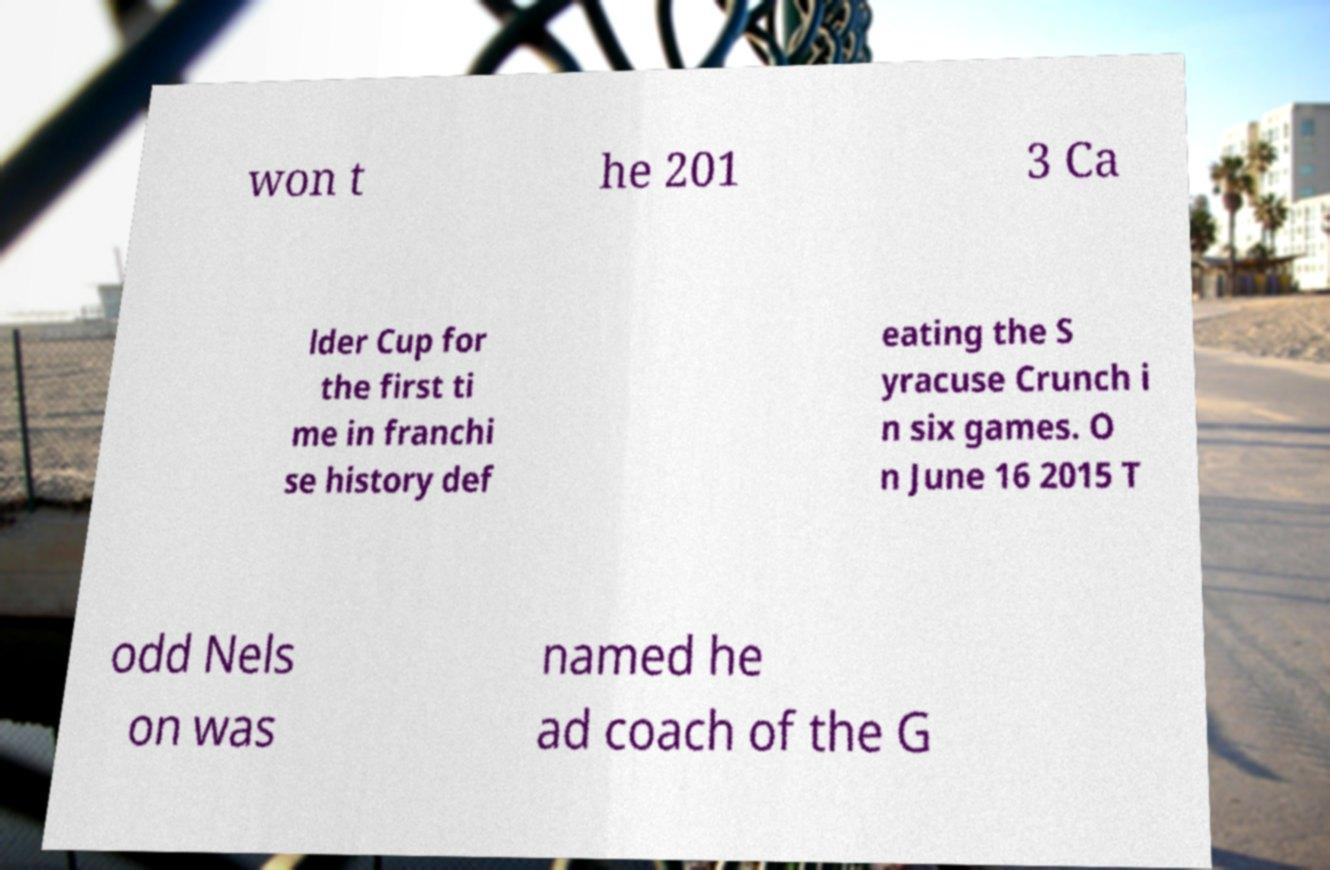Could you assist in decoding the text presented in this image and type it out clearly? won t he 201 3 Ca lder Cup for the first ti me in franchi se history def eating the S yracuse Crunch i n six games. O n June 16 2015 T odd Nels on was named he ad coach of the G 